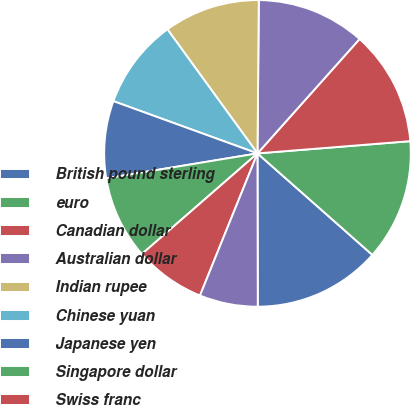Convert chart. <chart><loc_0><loc_0><loc_500><loc_500><pie_chart><fcel>British pound sterling<fcel>euro<fcel>Canadian dollar<fcel>Australian dollar<fcel>Indian rupee<fcel>Chinese yuan<fcel>Japanese yen<fcel>Singapore dollar<fcel>Swiss franc<fcel>Brazilian real<nl><fcel>13.45%<fcel>12.79%<fcel>12.13%<fcel>11.46%<fcel>10.13%<fcel>9.47%<fcel>8.14%<fcel>8.8%<fcel>7.48%<fcel>6.15%<nl></chart> 